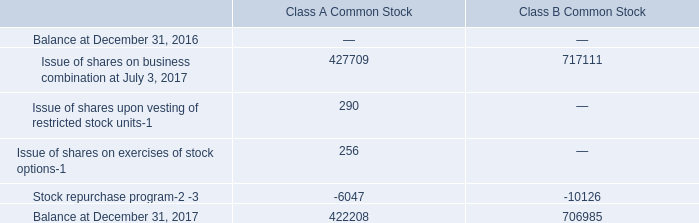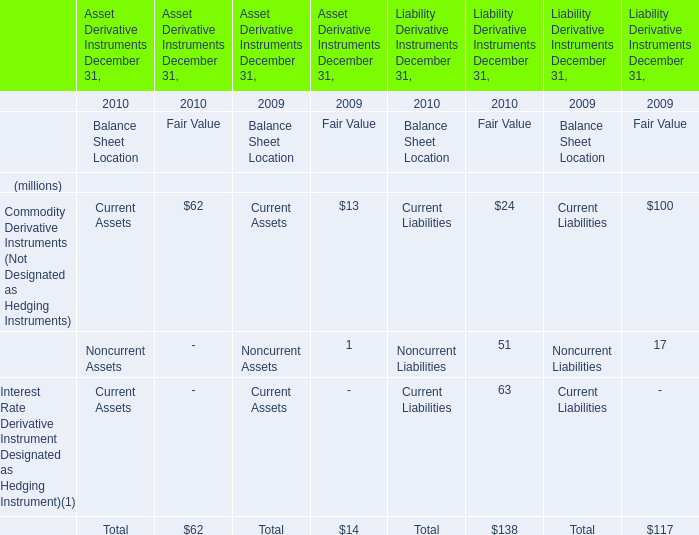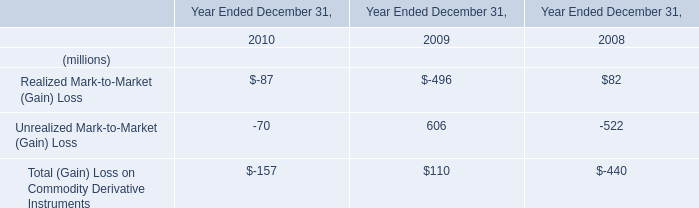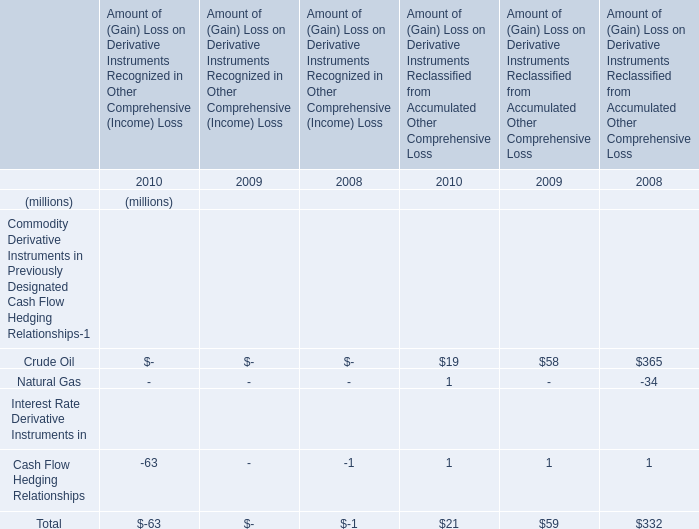What is the growing rate of Noncurrent Liabilities in the year with the most Commodity Derivative Instruments (Not Designated as Hedging Instruments for Liability Derivative Instruments December 31,? 
Computations: ((51 - 17) / 17)
Answer: 2.0. 